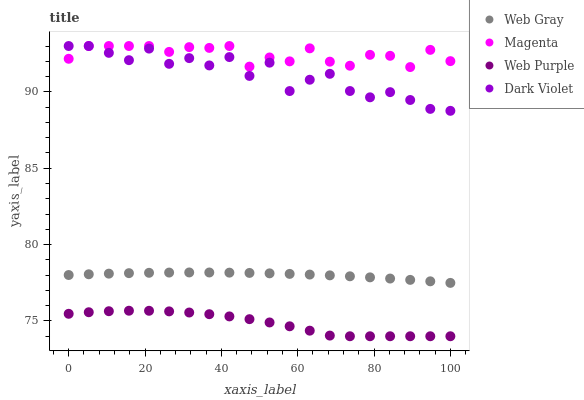Does Web Purple have the minimum area under the curve?
Answer yes or no. Yes. Does Magenta have the maximum area under the curve?
Answer yes or no. Yes. Does Web Gray have the minimum area under the curve?
Answer yes or no. No. Does Web Gray have the maximum area under the curve?
Answer yes or no. No. Is Web Gray the smoothest?
Answer yes or no. Yes. Is Dark Violet the roughest?
Answer yes or no. Yes. Is Web Purple the smoothest?
Answer yes or no. No. Is Web Purple the roughest?
Answer yes or no. No. Does Web Purple have the lowest value?
Answer yes or no. Yes. Does Web Gray have the lowest value?
Answer yes or no. No. Does Dark Violet have the highest value?
Answer yes or no. Yes. Does Web Gray have the highest value?
Answer yes or no. No. Is Web Purple less than Dark Violet?
Answer yes or no. Yes. Is Web Gray greater than Web Purple?
Answer yes or no. Yes. Does Magenta intersect Dark Violet?
Answer yes or no. Yes. Is Magenta less than Dark Violet?
Answer yes or no. No. Is Magenta greater than Dark Violet?
Answer yes or no. No. Does Web Purple intersect Dark Violet?
Answer yes or no. No. 